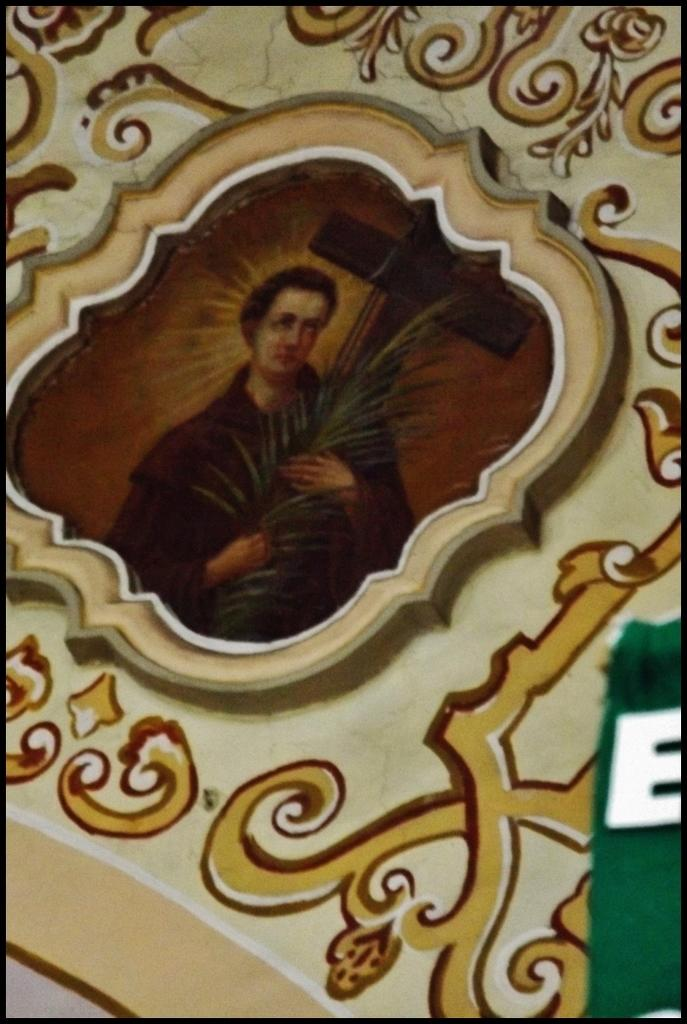What type of artwork is depicted in the image? The image is a painting. Who or what is the main subject of the painting? There is a man in the painting. What is the man doing in the painting? The man is holding the leaves of a plant. How does the man use the mitten in the painting? There is no mitten present in the painting; the man is holding the leaves of a plant. What causes the earthquake in the painting? There is no earthquake depicted in the painting; it features a man holding the leaves of a plant. 